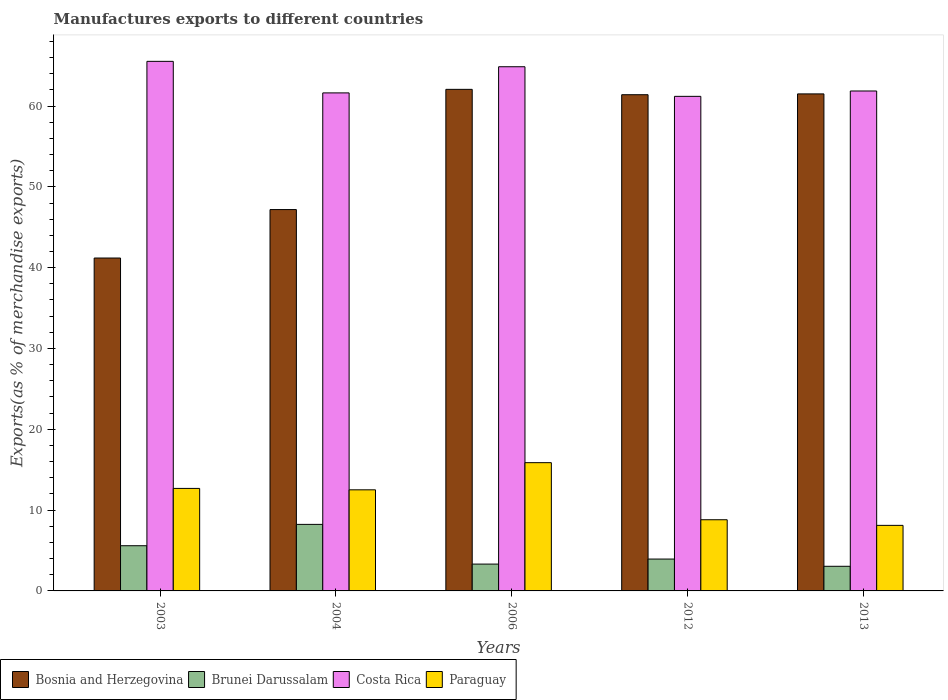How many different coloured bars are there?
Ensure brevity in your answer.  4. How many groups of bars are there?
Your response must be concise. 5. Are the number of bars on each tick of the X-axis equal?
Provide a short and direct response. Yes. How many bars are there on the 3rd tick from the right?
Offer a terse response. 4. What is the label of the 2nd group of bars from the left?
Give a very brief answer. 2004. What is the percentage of exports to different countries in Brunei Darussalam in 2003?
Offer a very short reply. 5.59. Across all years, what is the maximum percentage of exports to different countries in Paraguay?
Give a very brief answer. 15.87. Across all years, what is the minimum percentage of exports to different countries in Paraguay?
Provide a succinct answer. 8.11. In which year was the percentage of exports to different countries in Paraguay maximum?
Ensure brevity in your answer.  2006. In which year was the percentage of exports to different countries in Paraguay minimum?
Your answer should be compact. 2013. What is the total percentage of exports to different countries in Bosnia and Herzegovina in the graph?
Your response must be concise. 273.35. What is the difference between the percentage of exports to different countries in Bosnia and Herzegovina in 2004 and that in 2006?
Make the answer very short. -14.88. What is the difference between the percentage of exports to different countries in Paraguay in 2012 and the percentage of exports to different countries in Costa Rica in 2004?
Offer a terse response. -52.82. What is the average percentage of exports to different countries in Paraguay per year?
Offer a very short reply. 11.6. In the year 2013, what is the difference between the percentage of exports to different countries in Brunei Darussalam and percentage of exports to different countries in Costa Rica?
Provide a short and direct response. -58.81. In how many years, is the percentage of exports to different countries in Brunei Darussalam greater than 48 %?
Your answer should be very brief. 0. What is the ratio of the percentage of exports to different countries in Bosnia and Herzegovina in 2003 to that in 2004?
Keep it short and to the point. 0.87. Is the percentage of exports to different countries in Paraguay in 2006 less than that in 2013?
Give a very brief answer. No. What is the difference between the highest and the second highest percentage of exports to different countries in Brunei Darussalam?
Ensure brevity in your answer.  2.64. What is the difference between the highest and the lowest percentage of exports to different countries in Brunei Darussalam?
Give a very brief answer. 5.19. In how many years, is the percentage of exports to different countries in Paraguay greater than the average percentage of exports to different countries in Paraguay taken over all years?
Your response must be concise. 3. What does the 2nd bar from the left in 2013 represents?
Give a very brief answer. Brunei Darussalam. What does the 1st bar from the right in 2004 represents?
Make the answer very short. Paraguay. Is it the case that in every year, the sum of the percentage of exports to different countries in Brunei Darussalam and percentage of exports to different countries in Bosnia and Herzegovina is greater than the percentage of exports to different countries in Costa Rica?
Offer a very short reply. No. Are all the bars in the graph horizontal?
Keep it short and to the point. No. Does the graph contain any zero values?
Give a very brief answer. No. Does the graph contain grids?
Give a very brief answer. No. How are the legend labels stacked?
Your answer should be compact. Horizontal. What is the title of the graph?
Your response must be concise. Manufactures exports to different countries. Does "Trinidad and Tobago" appear as one of the legend labels in the graph?
Give a very brief answer. No. What is the label or title of the Y-axis?
Offer a very short reply. Exports(as % of merchandise exports). What is the Exports(as % of merchandise exports) in Bosnia and Herzegovina in 2003?
Offer a terse response. 41.19. What is the Exports(as % of merchandise exports) in Brunei Darussalam in 2003?
Your response must be concise. 5.59. What is the Exports(as % of merchandise exports) of Costa Rica in 2003?
Provide a short and direct response. 65.53. What is the Exports(as % of merchandise exports) of Paraguay in 2003?
Ensure brevity in your answer.  12.68. What is the Exports(as % of merchandise exports) in Bosnia and Herzegovina in 2004?
Ensure brevity in your answer.  47.19. What is the Exports(as % of merchandise exports) of Brunei Darussalam in 2004?
Ensure brevity in your answer.  8.23. What is the Exports(as % of merchandise exports) of Costa Rica in 2004?
Ensure brevity in your answer.  61.62. What is the Exports(as % of merchandise exports) in Paraguay in 2004?
Give a very brief answer. 12.51. What is the Exports(as % of merchandise exports) in Bosnia and Herzegovina in 2006?
Offer a terse response. 62.06. What is the Exports(as % of merchandise exports) of Brunei Darussalam in 2006?
Your response must be concise. 3.32. What is the Exports(as % of merchandise exports) in Costa Rica in 2006?
Provide a short and direct response. 64.86. What is the Exports(as % of merchandise exports) of Paraguay in 2006?
Ensure brevity in your answer.  15.87. What is the Exports(as % of merchandise exports) in Bosnia and Herzegovina in 2012?
Keep it short and to the point. 61.4. What is the Exports(as % of merchandise exports) in Brunei Darussalam in 2012?
Your answer should be compact. 3.94. What is the Exports(as % of merchandise exports) of Costa Rica in 2012?
Give a very brief answer. 61.2. What is the Exports(as % of merchandise exports) of Paraguay in 2012?
Your answer should be compact. 8.81. What is the Exports(as % of merchandise exports) of Bosnia and Herzegovina in 2013?
Offer a terse response. 61.5. What is the Exports(as % of merchandise exports) in Brunei Darussalam in 2013?
Offer a very short reply. 3.05. What is the Exports(as % of merchandise exports) in Costa Rica in 2013?
Offer a terse response. 61.86. What is the Exports(as % of merchandise exports) of Paraguay in 2013?
Offer a terse response. 8.11. Across all years, what is the maximum Exports(as % of merchandise exports) in Bosnia and Herzegovina?
Provide a succinct answer. 62.06. Across all years, what is the maximum Exports(as % of merchandise exports) of Brunei Darussalam?
Keep it short and to the point. 8.23. Across all years, what is the maximum Exports(as % of merchandise exports) of Costa Rica?
Ensure brevity in your answer.  65.53. Across all years, what is the maximum Exports(as % of merchandise exports) in Paraguay?
Ensure brevity in your answer.  15.87. Across all years, what is the minimum Exports(as % of merchandise exports) in Bosnia and Herzegovina?
Your answer should be compact. 41.19. Across all years, what is the minimum Exports(as % of merchandise exports) of Brunei Darussalam?
Your answer should be compact. 3.05. Across all years, what is the minimum Exports(as % of merchandise exports) of Costa Rica?
Keep it short and to the point. 61.2. Across all years, what is the minimum Exports(as % of merchandise exports) of Paraguay?
Offer a terse response. 8.11. What is the total Exports(as % of merchandise exports) of Bosnia and Herzegovina in the graph?
Offer a terse response. 273.35. What is the total Exports(as % of merchandise exports) in Brunei Darussalam in the graph?
Ensure brevity in your answer.  24.14. What is the total Exports(as % of merchandise exports) in Costa Rica in the graph?
Provide a short and direct response. 315.07. What is the total Exports(as % of merchandise exports) in Paraguay in the graph?
Your answer should be compact. 57.98. What is the difference between the Exports(as % of merchandise exports) in Bosnia and Herzegovina in 2003 and that in 2004?
Offer a terse response. -5.99. What is the difference between the Exports(as % of merchandise exports) of Brunei Darussalam in 2003 and that in 2004?
Make the answer very short. -2.64. What is the difference between the Exports(as % of merchandise exports) in Costa Rica in 2003 and that in 2004?
Give a very brief answer. 3.9. What is the difference between the Exports(as % of merchandise exports) of Paraguay in 2003 and that in 2004?
Keep it short and to the point. 0.17. What is the difference between the Exports(as % of merchandise exports) of Bosnia and Herzegovina in 2003 and that in 2006?
Your response must be concise. -20.87. What is the difference between the Exports(as % of merchandise exports) in Brunei Darussalam in 2003 and that in 2006?
Provide a short and direct response. 2.27. What is the difference between the Exports(as % of merchandise exports) of Costa Rica in 2003 and that in 2006?
Give a very brief answer. 0.67. What is the difference between the Exports(as % of merchandise exports) of Paraguay in 2003 and that in 2006?
Your response must be concise. -3.19. What is the difference between the Exports(as % of merchandise exports) of Bosnia and Herzegovina in 2003 and that in 2012?
Your answer should be compact. -20.21. What is the difference between the Exports(as % of merchandise exports) of Brunei Darussalam in 2003 and that in 2012?
Your answer should be compact. 1.65. What is the difference between the Exports(as % of merchandise exports) in Costa Rica in 2003 and that in 2012?
Offer a terse response. 4.33. What is the difference between the Exports(as % of merchandise exports) of Paraguay in 2003 and that in 2012?
Keep it short and to the point. 3.88. What is the difference between the Exports(as % of merchandise exports) in Bosnia and Herzegovina in 2003 and that in 2013?
Your answer should be compact. -20.31. What is the difference between the Exports(as % of merchandise exports) of Brunei Darussalam in 2003 and that in 2013?
Your answer should be compact. 2.55. What is the difference between the Exports(as % of merchandise exports) of Costa Rica in 2003 and that in 2013?
Your response must be concise. 3.67. What is the difference between the Exports(as % of merchandise exports) of Paraguay in 2003 and that in 2013?
Keep it short and to the point. 4.57. What is the difference between the Exports(as % of merchandise exports) in Bosnia and Herzegovina in 2004 and that in 2006?
Ensure brevity in your answer.  -14.88. What is the difference between the Exports(as % of merchandise exports) in Brunei Darussalam in 2004 and that in 2006?
Ensure brevity in your answer.  4.91. What is the difference between the Exports(as % of merchandise exports) in Costa Rica in 2004 and that in 2006?
Make the answer very short. -3.24. What is the difference between the Exports(as % of merchandise exports) in Paraguay in 2004 and that in 2006?
Your answer should be very brief. -3.36. What is the difference between the Exports(as % of merchandise exports) of Bosnia and Herzegovina in 2004 and that in 2012?
Give a very brief answer. -14.21. What is the difference between the Exports(as % of merchandise exports) in Brunei Darussalam in 2004 and that in 2012?
Keep it short and to the point. 4.29. What is the difference between the Exports(as % of merchandise exports) in Costa Rica in 2004 and that in 2012?
Make the answer very short. 0.43. What is the difference between the Exports(as % of merchandise exports) in Paraguay in 2004 and that in 2012?
Give a very brief answer. 3.7. What is the difference between the Exports(as % of merchandise exports) in Bosnia and Herzegovina in 2004 and that in 2013?
Make the answer very short. -14.31. What is the difference between the Exports(as % of merchandise exports) of Brunei Darussalam in 2004 and that in 2013?
Provide a short and direct response. 5.19. What is the difference between the Exports(as % of merchandise exports) in Costa Rica in 2004 and that in 2013?
Provide a succinct answer. -0.24. What is the difference between the Exports(as % of merchandise exports) of Paraguay in 2004 and that in 2013?
Keep it short and to the point. 4.4. What is the difference between the Exports(as % of merchandise exports) in Bosnia and Herzegovina in 2006 and that in 2012?
Make the answer very short. 0.66. What is the difference between the Exports(as % of merchandise exports) of Brunei Darussalam in 2006 and that in 2012?
Give a very brief answer. -0.62. What is the difference between the Exports(as % of merchandise exports) of Costa Rica in 2006 and that in 2012?
Your answer should be very brief. 3.66. What is the difference between the Exports(as % of merchandise exports) in Paraguay in 2006 and that in 2012?
Offer a terse response. 7.06. What is the difference between the Exports(as % of merchandise exports) in Bosnia and Herzegovina in 2006 and that in 2013?
Provide a succinct answer. 0.56. What is the difference between the Exports(as % of merchandise exports) of Brunei Darussalam in 2006 and that in 2013?
Your answer should be very brief. 0.27. What is the difference between the Exports(as % of merchandise exports) in Costa Rica in 2006 and that in 2013?
Your answer should be compact. 3. What is the difference between the Exports(as % of merchandise exports) in Paraguay in 2006 and that in 2013?
Your response must be concise. 7.76. What is the difference between the Exports(as % of merchandise exports) of Bosnia and Herzegovina in 2012 and that in 2013?
Your answer should be very brief. -0.1. What is the difference between the Exports(as % of merchandise exports) of Brunei Darussalam in 2012 and that in 2013?
Provide a short and direct response. 0.9. What is the difference between the Exports(as % of merchandise exports) in Costa Rica in 2012 and that in 2013?
Your answer should be very brief. -0.66. What is the difference between the Exports(as % of merchandise exports) of Paraguay in 2012 and that in 2013?
Keep it short and to the point. 0.7. What is the difference between the Exports(as % of merchandise exports) of Bosnia and Herzegovina in 2003 and the Exports(as % of merchandise exports) of Brunei Darussalam in 2004?
Ensure brevity in your answer.  32.96. What is the difference between the Exports(as % of merchandise exports) of Bosnia and Herzegovina in 2003 and the Exports(as % of merchandise exports) of Costa Rica in 2004?
Give a very brief answer. -20.43. What is the difference between the Exports(as % of merchandise exports) of Bosnia and Herzegovina in 2003 and the Exports(as % of merchandise exports) of Paraguay in 2004?
Offer a very short reply. 28.68. What is the difference between the Exports(as % of merchandise exports) in Brunei Darussalam in 2003 and the Exports(as % of merchandise exports) in Costa Rica in 2004?
Provide a succinct answer. -56.03. What is the difference between the Exports(as % of merchandise exports) in Brunei Darussalam in 2003 and the Exports(as % of merchandise exports) in Paraguay in 2004?
Offer a very short reply. -6.92. What is the difference between the Exports(as % of merchandise exports) in Costa Rica in 2003 and the Exports(as % of merchandise exports) in Paraguay in 2004?
Offer a very short reply. 53.02. What is the difference between the Exports(as % of merchandise exports) in Bosnia and Herzegovina in 2003 and the Exports(as % of merchandise exports) in Brunei Darussalam in 2006?
Offer a very short reply. 37.87. What is the difference between the Exports(as % of merchandise exports) of Bosnia and Herzegovina in 2003 and the Exports(as % of merchandise exports) of Costa Rica in 2006?
Provide a succinct answer. -23.67. What is the difference between the Exports(as % of merchandise exports) in Bosnia and Herzegovina in 2003 and the Exports(as % of merchandise exports) in Paraguay in 2006?
Your answer should be compact. 25.32. What is the difference between the Exports(as % of merchandise exports) of Brunei Darussalam in 2003 and the Exports(as % of merchandise exports) of Costa Rica in 2006?
Provide a short and direct response. -59.27. What is the difference between the Exports(as % of merchandise exports) of Brunei Darussalam in 2003 and the Exports(as % of merchandise exports) of Paraguay in 2006?
Your answer should be compact. -10.28. What is the difference between the Exports(as % of merchandise exports) in Costa Rica in 2003 and the Exports(as % of merchandise exports) in Paraguay in 2006?
Your answer should be very brief. 49.66. What is the difference between the Exports(as % of merchandise exports) of Bosnia and Herzegovina in 2003 and the Exports(as % of merchandise exports) of Brunei Darussalam in 2012?
Offer a very short reply. 37.25. What is the difference between the Exports(as % of merchandise exports) of Bosnia and Herzegovina in 2003 and the Exports(as % of merchandise exports) of Costa Rica in 2012?
Offer a very short reply. -20. What is the difference between the Exports(as % of merchandise exports) of Bosnia and Herzegovina in 2003 and the Exports(as % of merchandise exports) of Paraguay in 2012?
Provide a short and direct response. 32.39. What is the difference between the Exports(as % of merchandise exports) of Brunei Darussalam in 2003 and the Exports(as % of merchandise exports) of Costa Rica in 2012?
Ensure brevity in your answer.  -55.6. What is the difference between the Exports(as % of merchandise exports) in Brunei Darussalam in 2003 and the Exports(as % of merchandise exports) in Paraguay in 2012?
Provide a short and direct response. -3.21. What is the difference between the Exports(as % of merchandise exports) of Costa Rica in 2003 and the Exports(as % of merchandise exports) of Paraguay in 2012?
Give a very brief answer. 56.72. What is the difference between the Exports(as % of merchandise exports) in Bosnia and Herzegovina in 2003 and the Exports(as % of merchandise exports) in Brunei Darussalam in 2013?
Keep it short and to the point. 38.15. What is the difference between the Exports(as % of merchandise exports) of Bosnia and Herzegovina in 2003 and the Exports(as % of merchandise exports) of Costa Rica in 2013?
Provide a short and direct response. -20.67. What is the difference between the Exports(as % of merchandise exports) in Bosnia and Herzegovina in 2003 and the Exports(as % of merchandise exports) in Paraguay in 2013?
Give a very brief answer. 33.08. What is the difference between the Exports(as % of merchandise exports) of Brunei Darussalam in 2003 and the Exports(as % of merchandise exports) of Costa Rica in 2013?
Give a very brief answer. -56.27. What is the difference between the Exports(as % of merchandise exports) of Brunei Darussalam in 2003 and the Exports(as % of merchandise exports) of Paraguay in 2013?
Ensure brevity in your answer.  -2.52. What is the difference between the Exports(as % of merchandise exports) in Costa Rica in 2003 and the Exports(as % of merchandise exports) in Paraguay in 2013?
Make the answer very short. 57.42. What is the difference between the Exports(as % of merchandise exports) in Bosnia and Herzegovina in 2004 and the Exports(as % of merchandise exports) in Brunei Darussalam in 2006?
Your response must be concise. 43.87. What is the difference between the Exports(as % of merchandise exports) of Bosnia and Herzegovina in 2004 and the Exports(as % of merchandise exports) of Costa Rica in 2006?
Ensure brevity in your answer.  -17.68. What is the difference between the Exports(as % of merchandise exports) of Bosnia and Herzegovina in 2004 and the Exports(as % of merchandise exports) of Paraguay in 2006?
Give a very brief answer. 31.32. What is the difference between the Exports(as % of merchandise exports) in Brunei Darussalam in 2004 and the Exports(as % of merchandise exports) in Costa Rica in 2006?
Ensure brevity in your answer.  -56.63. What is the difference between the Exports(as % of merchandise exports) of Brunei Darussalam in 2004 and the Exports(as % of merchandise exports) of Paraguay in 2006?
Give a very brief answer. -7.64. What is the difference between the Exports(as % of merchandise exports) in Costa Rica in 2004 and the Exports(as % of merchandise exports) in Paraguay in 2006?
Offer a terse response. 45.75. What is the difference between the Exports(as % of merchandise exports) of Bosnia and Herzegovina in 2004 and the Exports(as % of merchandise exports) of Brunei Darussalam in 2012?
Provide a short and direct response. 43.24. What is the difference between the Exports(as % of merchandise exports) in Bosnia and Herzegovina in 2004 and the Exports(as % of merchandise exports) in Costa Rica in 2012?
Provide a succinct answer. -14.01. What is the difference between the Exports(as % of merchandise exports) of Bosnia and Herzegovina in 2004 and the Exports(as % of merchandise exports) of Paraguay in 2012?
Keep it short and to the point. 38.38. What is the difference between the Exports(as % of merchandise exports) in Brunei Darussalam in 2004 and the Exports(as % of merchandise exports) in Costa Rica in 2012?
Offer a terse response. -52.96. What is the difference between the Exports(as % of merchandise exports) of Brunei Darussalam in 2004 and the Exports(as % of merchandise exports) of Paraguay in 2012?
Your answer should be compact. -0.57. What is the difference between the Exports(as % of merchandise exports) in Costa Rica in 2004 and the Exports(as % of merchandise exports) in Paraguay in 2012?
Your answer should be compact. 52.82. What is the difference between the Exports(as % of merchandise exports) of Bosnia and Herzegovina in 2004 and the Exports(as % of merchandise exports) of Brunei Darussalam in 2013?
Provide a short and direct response. 44.14. What is the difference between the Exports(as % of merchandise exports) in Bosnia and Herzegovina in 2004 and the Exports(as % of merchandise exports) in Costa Rica in 2013?
Offer a terse response. -14.67. What is the difference between the Exports(as % of merchandise exports) in Bosnia and Herzegovina in 2004 and the Exports(as % of merchandise exports) in Paraguay in 2013?
Keep it short and to the point. 39.08. What is the difference between the Exports(as % of merchandise exports) in Brunei Darussalam in 2004 and the Exports(as % of merchandise exports) in Costa Rica in 2013?
Your answer should be very brief. -53.63. What is the difference between the Exports(as % of merchandise exports) in Brunei Darussalam in 2004 and the Exports(as % of merchandise exports) in Paraguay in 2013?
Your response must be concise. 0.12. What is the difference between the Exports(as % of merchandise exports) of Costa Rica in 2004 and the Exports(as % of merchandise exports) of Paraguay in 2013?
Give a very brief answer. 53.51. What is the difference between the Exports(as % of merchandise exports) of Bosnia and Herzegovina in 2006 and the Exports(as % of merchandise exports) of Brunei Darussalam in 2012?
Offer a very short reply. 58.12. What is the difference between the Exports(as % of merchandise exports) of Bosnia and Herzegovina in 2006 and the Exports(as % of merchandise exports) of Costa Rica in 2012?
Keep it short and to the point. 0.87. What is the difference between the Exports(as % of merchandise exports) of Bosnia and Herzegovina in 2006 and the Exports(as % of merchandise exports) of Paraguay in 2012?
Make the answer very short. 53.26. What is the difference between the Exports(as % of merchandise exports) of Brunei Darussalam in 2006 and the Exports(as % of merchandise exports) of Costa Rica in 2012?
Provide a succinct answer. -57.88. What is the difference between the Exports(as % of merchandise exports) in Brunei Darussalam in 2006 and the Exports(as % of merchandise exports) in Paraguay in 2012?
Offer a very short reply. -5.49. What is the difference between the Exports(as % of merchandise exports) in Costa Rica in 2006 and the Exports(as % of merchandise exports) in Paraguay in 2012?
Keep it short and to the point. 56.06. What is the difference between the Exports(as % of merchandise exports) in Bosnia and Herzegovina in 2006 and the Exports(as % of merchandise exports) in Brunei Darussalam in 2013?
Offer a terse response. 59.02. What is the difference between the Exports(as % of merchandise exports) of Bosnia and Herzegovina in 2006 and the Exports(as % of merchandise exports) of Costa Rica in 2013?
Your answer should be compact. 0.2. What is the difference between the Exports(as % of merchandise exports) in Bosnia and Herzegovina in 2006 and the Exports(as % of merchandise exports) in Paraguay in 2013?
Offer a very short reply. 53.95. What is the difference between the Exports(as % of merchandise exports) in Brunei Darussalam in 2006 and the Exports(as % of merchandise exports) in Costa Rica in 2013?
Give a very brief answer. -58.54. What is the difference between the Exports(as % of merchandise exports) of Brunei Darussalam in 2006 and the Exports(as % of merchandise exports) of Paraguay in 2013?
Make the answer very short. -4.79. What is the difference between the Exports(as % of merchandise exports) in Costa Rica in 2006 and the Exports(as % of merchandise exports) in Paraguay in 2013?
Offer a terse response. 56.75. What is the difference between the Exports(as % of merchandise exports) of Bosnia and Herzegovina in 2012 and the Exports(as % of merchandise exports) of Brunei Darussalam in 2013?
Offer a terse response. 58.35. What is the difference between the Exports(as % of merchandise exports) of Bosnia and Herzegovina in 2012 and the Exports(as % of merchandise exports) of Costa Rica in 2013?
Provide a short and direct response. -0.46. What is the difference between the Exports(as % of merchandise exports) in Bosnia and Herzegovina in 2012 and the Exports(as % of merchandise exports) in Paraguay in 2013?
Offer a terse response. 53.29. What is the difference between the Exports(as % of merchandise exports) of Brunei Darussalam in 2012 and the Exports(as % of merchandise exports) of Costa Rica in 2013?
Offer a very short reply. -57.92. What is the difference between the Exports(as % of merchandise exports) of Brunei Darussalam in 2012 and the Exports(as % of merchandise exports) of Paraguay in 2013?
Your answer should be compact. -4.17. What is the difference between the Exports(as % of merchandise exports) in Costa Rica in 2012 and the Exports(as % of merchandise exports) in Paraguay in 2013?
Make the answer very short. 53.09. What is the average Exports(as % of merchandise exports) of Bosnia and Herzegovina per year?
Keep it short and to the point. 54.67. What is the average Exports(as % of merchandise exports) of Brunei Darussalam per year?
Ensure brevity in your answer.  4.83. What is the average Exports(as % of merchandise exports) in Costa Rica per year?
Offer a terse response. 63.01. What is the average Exports(as % of merchandise exports) in Paraguay per year?
Provide a succinct answer. 11.6. In the year 2003, what is the difference between the Exports(as % of merchandise exports) of Bosnia and Herzegovina and Exports(as % of merchandise exports) of Brunei Darussalam?
Your answer should be very brief. 35.6. In the year 2003, what is the difference between the Exports(as % of merchandise exports) in Bosnia and Herzegovina and Exports(as % of merchandise exports) in Costa Rica?
Your answer should be compact. -24.34. In the year 2003, what is the difference between the Exports(as % of merchandise exports) in Bosnia and Herzegovina and Exports(as % of merchandise exports) in Paraguay?
Keep it short and to the point. 28.51. In the year 2003, what is the difference between the Exports(as % of merchandise exports) of Brunei Darussalam and Exports(as % of merchandise exports) of Costa Rica?
Make the answer very short. -59.94. In the year 2003, what is the difference between the Exports(as % of merchandise exports) of Brunei Darussalam and Exports(as % of merchandise exports) of Paraguay?
Your answer should be very brief. -7.09. In the year 2003, what is the difference between the Exports(as % of merchandise exports) in Costa Rica and Exports(as % of merchandise exports) in Paraguay?
Give a very brief answer. 52.84. In the year 2004, what is the difference between the Exports(as % of merchandise exports) of Bosnia and Herzegovina and Exports(as % of merchandise exports) of Brunei Darussalam?
Give a very brief answer. 38.95. In the year 2004, what is the difference between the Exports(as % of merchandise exports) of Bosnia and Herzegovina and Exports(as % of merchandise exports) of Costa Rica?
Your answer should be compact. -14.44. In the year 2004, what is the difference between the Exports(as % of merchandise exports) in Bosnia and Herzegovina and Exports(as % of merchandise exports) in Paraguay?
Offer a terse response. 34.68. In the year 2004, what is the difference between the Exports(as % of merchandise exports) of Brunei Darussalam and Exports(as % of merchandise exports) of Costa Rica?
Make the answer very short. -53.39. In the year 2004, what is the difference between the Exports(as % of merchandise exports) of Brunei Darussalam and Exports(as % of merchandise exports) of Paraguay?
Provide a succinct answer. -4.28. In the year 2004, what is the difference between the Exports(as % of merchandise exports) of Costa Rica and Exports(as % of merchandise exports) of Paraguay?
Your response must be concise. 49.12. In the year 2006, what is the difference between the Exports(as % of merchandise exports) of Bosnia and Herzegovina and Exports(as % of merchandise exports) of Brunei Darussalam?
Offer a terse response. 58.74. In the year 2006, what is the difference between the Exports(as % of merchandise exports) of Bosnia and Herzegovina and Exports(as % of merchandise exports) of Costa Rica?
Provide a short and direct response. -2.8. In the year 2006, what is the difference between the Exports(as % of merchandise exports) in Bosnia and Herzegovina and Exports(as % of merchandise exports) in Paraguay?
Your answer should be compact. 46.19. In the year 2006, what is the difference between the Exports(as % of merchandise exports) in Brunei Darussalam and Exports(as % of merchandise exports) in Costa Rica?
Offer a very short reply. -61.54. In the year 2006, what is the difference between the Exports(as % of merchandise exports) of Brunei Darussalam and Exports(as % of merchandise exports) of Paraguay?
Ensure brevity in your answer.  -12.55. In the year 2006, what is the difference between the Exports(as % of merchandise exports) in Costa Rica and Exports(as % of merchandise exports) in Paraguay?
Offer a very short reply. 48.99. In the year 2012, what is the difference between the Exports(as % of merchandise exports) of Bosnia and Herzegovina and Exports(as % of merchandise exports) of Brunei Darussalam?
Give a very brief answer. 57.46. In the year 2012, what is the difference between the Exports(as % of merchandise exports) of Bosnia and Herzegovina and Exports(as % of merchandise exports) of Costa Rica?
Provide a succinct answer. 0.2. In the year 2012, what is the difference between the Exports(as % of merchandise exports) of Bosnia and Herzegovina and Exports(as % of merchandise exports) of Paraguay?
Provide a short and direct response. 52.59. In the year 2012, what is the difference between the Exports(as % of merchandise exports) in Brunei Darussalam and Exports(as % of merchandise exports) in Costa Rica?
Provide a short and direct response. -57.25. In the year 2012, what is the difference between the Exports(as % of merchandise exports) of Brunei Darussalam and Exports(as % of merchandise exports) of Paraguay?
Make the answer very short. -4.86. In the year 2012, what is the difference between the Exports(as % of merchandise exports) of Costa Rica and Exports(as % of merchandise exports) of Paraguay?
Make the answer very short. 52.39. In the year 2013, what is the difference between the Exports(as % of merchandise exports) in Bosnia and Herzegovina and Exports(as % of merchandise exports) in Brunei Darussalam?
Offer a very short reply. 58.45. In the year 2013, what is the difference between the Exports(as % of merchandise exports) of Bosnia and Herzegovina and Exports(as % of merchandise exports) of Costa Rica?
Your answer should be compact. -0.36. In the year 2013, what is the difference between the Exports(as % of merchandise exports) of Bosnia and Herzegovina and Exports(as % of merchandise exports) of Paraguay?
Your answer should be very brief. 53.39. In the year 2013, what is the difference between the Exports(as % of merchandise exports) of Brunei Darussalam and Exports(as % of merchandise exports) of Costa Rica?
Your answer should be compact. -58.81. In the year 2013, what is the difference between the Exports(as % of merchandise exports) of Brunei Darussalam and Exports(as % of merchandise exports) of Paraguay?
Make the answer very short. -5.06. In the year 2013, what is the difference between the Exports(as % of merchandise exports) of Costa Rica and Exports(as % of merchandise exports) of Paraguay?
Your answer should be compact. 53.75. What is the ratio of the Exports(as % of merchandise exports) of Bosnia and Herzegovina in 2003 to that in 2004?
Offer a very short reply. 0.87. What is the ratio of the Exports(as % of merchandise exports) of Brunei Darussalam in 2003 to that in 2004?
Provide a short and direct response. 0.68. What is the ratio of the Exports(as % of merchandise exports) in Costa Rica in 2003 to that in 2004?
Keep it short and to the point. 1.06. What is the ratio of the Exports(as % of merchandise exports) of Paraguay in 2003 to that in 2004?
Keep it short and to the point. 1.01. What is the ratio of the Exports(as % of merchandise exports) in Bosnia and Herzegovina in 2003 to that in 2006?
Keep it short and to the point. 0.66. What is the ratio of the Exports(as % of merchandise exports) of Brunei Darussalam in 2003 to that in 2006?
Your response must be concise. 1.68. What is the ratio of the Exports(as % of merchandise exports) of Costa Rica in 2003 to that in 2006?
Provide a succinct answer. 1.01. What is the ratio of the Exports(as % of merchandise exports) in Paraguay in 2003 to that in 2006?
Your response must be concise. 0.8. What is the ratio of the Exports(as % of merchandise exports) of Bosnia and Herzegovina in 2003 to that in 2012?
Provide a short and direct response. 0.67. What is the ratio of the Exports(as % of merchandise exports) in Brunei Darussalam in 2003 to that in 2012?
Your answer should be very brief. 1.42. What is the ratio of the Exports(as % of merchandise exports) in Costa Rica in 2003 to that in 2012?
Your answer should be very brief. 1.07. What is the ratio of the Exports(as % of merchandise exports) in Paraguay in 2003 to that in 2012?
Make the answer very short. 1.44. What is the ratio of the Exports(as % of merchandise exports) in Bosnia and Herzegovina in 2003 to that in 2013?
Offer a very short reply. 0.67. What is the ratio of the Exports(as % of merchandise exports) in Brunei Darussalam in 2003 to that in 2013?
Give a very brief answer. 1.84. What is the ratio of the Exports(as % of merchandise exports) in Costa Rica in 2003 to that in 2013?
Provide a short and direct response. 1.06. What is the ratio of the Exports(as % of merchandise exports) in Paraguay in 2003 to that in 2013?
Give a very brief answer. 1.56. What is the ratio of the Exports(as % of merchandise exports) in Bosnia and Herzegovina in 2004 to that in 2006?
Keep it short and to the point. 0.76. What is the ratio of the Exports(as % of merchandise exports) in Brunei Darussalam in 2004 to that in 2006?
Offer a terse response. 2.48. What is the ratio of the Exports(as % of merchandise exports) in Costa Rica in 2004 to that in 2006?
Offer a very short reply. 0.95. What is the ratio of the Exports(as % of merchandise exports) in Paraguay in 2004 to that in 2006?
Ensure brevity in your answer.  0.79. What is the ratio of the Exports(as % of merchandise exports) of Bosnia and Herzegovina in 2004 to that in 2012?
Ensure brevity in your answer.  0.77. What is the ratio of the Exports(as % of merchandise exports) of Brunei Darussalam in 2004 to that in 2012?
Ensure brevity in your answer.  2.09. What is the ratio of the Exports(as % of merchandise exports) in Costa Rica in 2004 to that in 2012?
Ensure brevity in your answer.  1.01. What is the ratio of the Exports(as % of merchandise exports) in Paraguay in 2004 to that in 2012?
Provide a short and direct response. 1.42. What is the ratio of the Exports(as % of merchandise exports) in Bosnia and Herzegovina in 2004 to that in 2013?
Offer a terse response. 0.77. What is the ratio of the Exports(as % of merchandise exports) of Brunei Darussalam in 2004 to that in 2013?
Give a very brief answer. 2.7. What is the ratio of the Exports(as % of merchandise exports) of Costa Rica in 2004 to that in 2013?
Give a very brief answer. 1. What is the ratio of the Exports(as % of merchandise exports) in Paraguay in 2004 to that in 2013?
Your answer should be very brief. 1.54. What is the ratio of the Exports(as % of merchandise exports) of Bosnia and Herzegovina in 2006 to that in 2012?
Make the answer very short. 1.01. What is the ratio of the Exports(as % of merchandise exports) in Brunei Darussalam in 2006 to that in 2012?
Your answer should be compact. 0.84. What is the ratio of the Exports(as % of merchandise exports) in Costa Rica in 2006 to that in 2012?
Provide a succinct answer. 1.06. What is the ratio of the Exports(as % of merchandise exports) of Paraguay in 2006 to that in 2012?
Provide a succinct answer. 1.8. What is the ratio of the Exports(as % of merchandise exports) of Bosnia and Herzegovina in 2006 to that in 2013?
Your response must be concise. 1.01. What is the ratio of the Exports(as % of merchandise exports) of Brunei Darussalam in 2006 to that in 2013?
Provide a short and direct response. 1.09. What is the ratio of the Exports(as % of merchandise exports) in Costa Rica in 2006 to that in 2013?
Give a very brief answer. 1.05. What is the ratio of the Exports(as % of merchandise exports) in Paraguay in 2006 to that in 2013?
Provide a succinct answer. 1.96. What is the ratio of the Exports(as % of merchandise exports) of Bosnia and Herzegovina in 2012 to that in 2013?
Offer a very short reply. 1. What is the ratio of the Exports(as % of merchandise exports) of Brunei Darussalam in 2012 to that in 2013?
Ensure brevity in your answer.  1.29. What is the ratio of the Exports(as % of merchandise exports) of Costa Rica in 2012 to that in 2013?
Keep it short and to the point. 0.99. What is the ratio of the Exports(as % of merchandise exports) of Paraguay in 2012 to that in 2013?
Offer a very short reply. 1.09. What is the difference between the highest and the second highest Exports(as % of merchandise exports) in Bosnia and Herzegovina?
Your answer should be compact. 0.56. What is the difference between the highest and the second highest Exports(as % of merchandise exports) of Brunei Darussalam?
Your answer should be very brief. 2.64. What is the difference between the highest and the second highest Exports(as % of merchandise exports) of Costa Rica?
Give a very brief answer. 0.67. What is the difference between the highest and the second highest Exports(as % of merchandise exports) of Paraguay?
Give a very brief answer. 3.19. What is the difference between the highest and the lowest Exports(as % of merchandise exports) in Bosnia and Herzegovina?
Your answer should be very brief. 20.87. What is the difference between the highest and the lowest Exports(as % of merchandise exports) of Brunei Darussalam?
Ensure brevity in your answer.  5.19. What is the difference between the highest and the lowest Exports(as % of merchandise exports) in Costa Rica?
Give a very brief answer. 4.33. What is the difference between the highest and the lowest Exports(as % of merchandise exports) of Paraguay?
Provide a succinct answer. 7.76. 